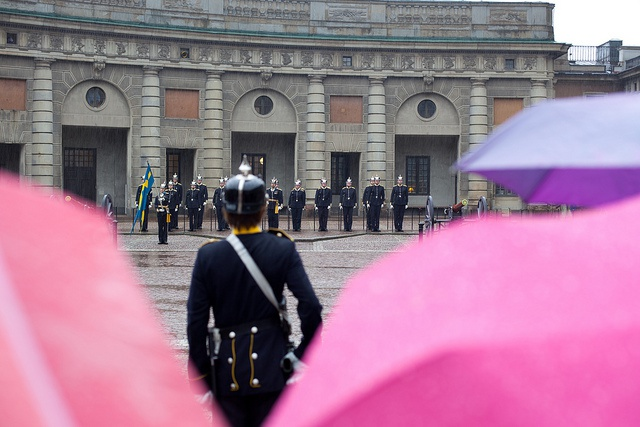Describe the objects in this image and their specific colors. I can see umbrella in gray, violet, and black tones, umbrella in gray, lightpink, and violet tones, people in gray, black, and darkgray tones, umbrella in gray, lavender, and purple tones, and people in gray, black, and darkgray tones in this image. 